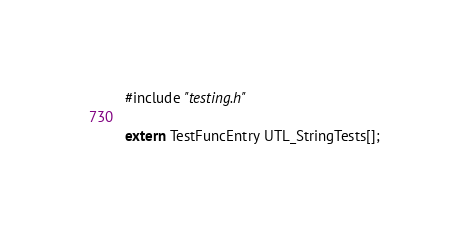<code> <loc_0><loc_0><loc_500><loc_500><_C_>#include "testing.h"

extern TestFuncEntry UTL_StringTests[];
</code> 